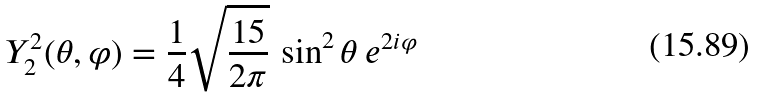<formula> <loc_0><loc_0><loc_500><loc_500>Y _ { 2 } ^ { 2 } ( \theta , \varphi ) = { \frac { 1 } { 4 } } { \sqrt { \frac { 1 5 } { 2 \pi } } } \, \sin ^ { 2 } \theta \, e ^ { 2 i \varphi }</formula> 